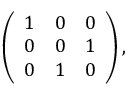<formula> <loc_0><loc_0><loc_500><loc_500>\left ( \begin{array} { c c c } { 1 } & { 0 } & { 0 } \\ { 0 } & { 0 } & { 1 } \\ { 0 } & { 1 } & { 0 } \end{array} \right ) ,</formula> 